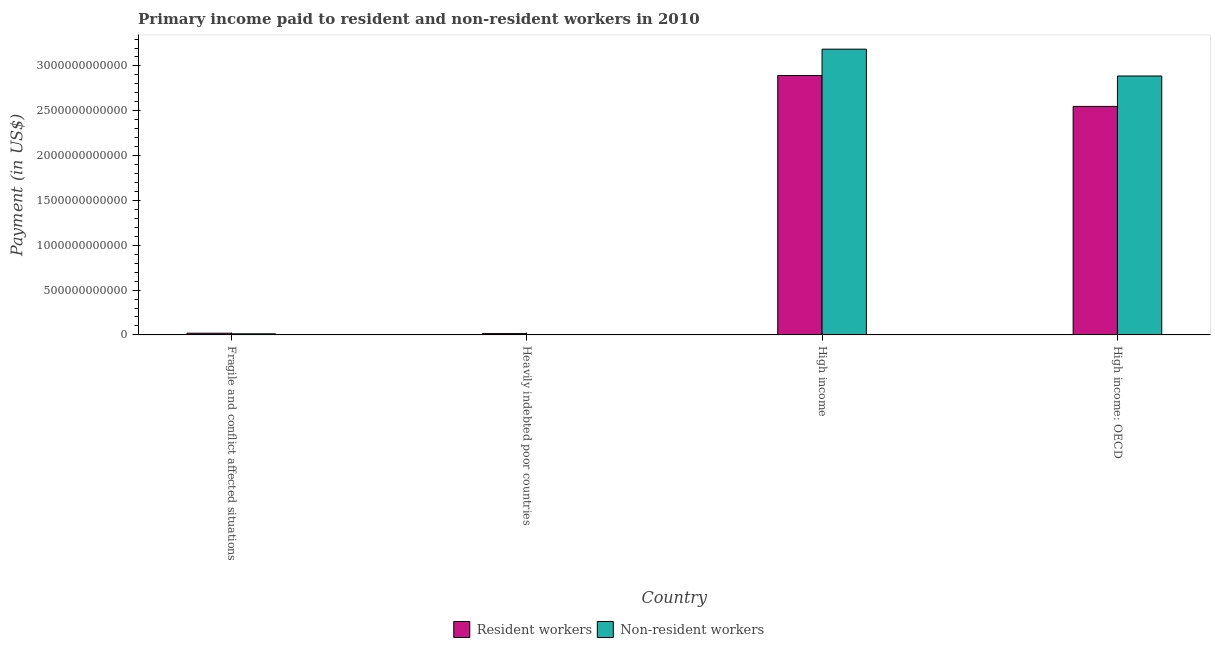Are the number of bars per tick equal to the number of legend labels?
Make the answer very short. Yes. How many bars are there on the 2nd tick from the left?
Your response must be concise. 2. What is the label of the 2nd group of bars from the left?
Ensure brevity in your answer.  Heavily indebted poor countries. In how many cases, is the number of bars for a given country not equal to the number of legend labels?
Provide a short and direct response. 0. What is the payment made to non-resident workers in High income?
Your response must be concise. 3.19e+12. Across all countries, what is the maximum payment made to non-resident workers?
Ensure brevity in your answer.  3.19e+12. Across all countries, what is the minimum payment made to resident workers?
Provide a succinct answer. 1.46e+1. In which country was the payment made to resident workers minimum?
Offer a terse response. Heavily indebted poor countries. What is the total payment made to resident workers in the graph?
Make the answer very short. 5.48e+12. What is the difference between the payment made to non-resident workers in Fragile and conflict affected situations and that in High income: OECD?
Keep it short and to the point. -2.88e+12. What is the difference between the payment made to resident workers in High income and the payment made to non-resident workers in Fragile and conflict affected situations?
Offer a very short reply. 2.88e+12. What is the average payment made to non-resident workers per country?
Provide a short and direct response. 1.52e+12. What is the difference between the payment made to resident workers and payment made to non-resident workers in High income: OECD?
Offer a very short reply. -3.39e+11. In how many countries, is the payment made to non-resident workers greater than 1200000000000 US$?
Your response must be concise. 2. What is the ratio of the payment made to resident workers in Fragile and conflict affected situations to that in High income?
Your answer should be very brief. 0.01. Is the difference between the payment made to resident workers in High income and High income: OECD greater than the difference between the payment made to non-resident workers in High income and High income: OECD?
Provide a short and direct response. Yes. What is the difference between the highest and the second highest payment made to non-resident workers?
Your response must be concise. 2.99e+11. What is the difference between the highest and the lowest payment made to resident workers?
Offer a very short reply. 2.88e+12. In how many countries, is the payment made to non-resident workers greater than the average payment made to non-resident workers taken over all countries?
Your answer should be compact. 2. Is the sum of the payment made to resident workers in High income and High income: OECD greater than the maximum payment made to non-resident workers across all countries?
Offer a very short reply. Yes. What does the 1st bar from the left in Fragile and conflict affected situations represents?
Provide a succinct answer. Resident workers. What does the 1st bar from the right in High income: OECD represents?
Provide a succinct answer. Non-resident workers. How many bars are there?
Provide a short and direct response. 8. How many countries are there in the graph?
Your answer should be very brief. 4. What is the difference between two consecutive major ticks on the Y-axis?
Give a very brief answer. 5.00e+11. Are the values on the major ticks of Y-axis written in scientific E-notation?
Your answer should be compact. No. How many legend labels are there?
Give a very brief answer. 2. What is the title of the graph?
Offer a very short reply. Primary income paid to resident and non-resident workers in 2010. Does "Time to import" appear as one of the legend labels in the graph?
Your answer should be very brief. No. What is the label or title of the Y-axis?
Provide a short and direct response. Payment (in US$). What is the Payment (in US$) of Resident workers in Fragile and conflict affected situations?
Provide a short and direct response. 1.89e+1. What is the Payment (in US$) in Non-resident workers in Fragile and conflict affected situations?
Give a very brief answer. 1.21e+1. What is the Payment (in US$) in Resident workers in Heavily indebted poor countries?
Your response must be concise. 1.46e+1. What is the Payment (in US$) of Non-resident workers in Heavily indebted poor countries?
Your answer should be very brief. 2.23e+09. What is the Payment (in US$) of Resident workers in High income?
Provide a short and direct response. 2.89e+12. What is the Payment (in US$) of Non-resident workers in High income?
Give a very brief answer. 3.19e+12. What is the Payment (in US$) of Resident workers in High income: OECD?
Keep it short and to the point. 2.55e+12. What is the Payment (in US$) in Non-resident workers in High income: OECD?
Your answer should be compact. 2.89e+12. Across all countries, what is the maximum Payment (in US$) of Resident workers?
Make the answer very short. 2.89e+12. Across all countries, what is the maximum Payment (in US$) in Non-resident workers?
Provide a short and direct response. 3.19e+12. Across all countries, what is the minimum Payment (in US$) in Resident workers?
Provide a succinct answer. 1.46e+1. Across all countries, what is the minimum Payment (in US$) of Non-resident workers?
Keep it short and to the point. 2.23e+09. What is the total Payment (in US$) in Resident workers in the graph?
Keep it short and to the point. 5.48e+12. What is the total Payment (in US$) in Non-resident workers in the graph?
Your response must be concise. 6.09e+12. What is the difference between the Payment (in US$) in Resident workers in Fragile and conflict affected situations and that in Heavily indebted poor countries?
Your response must be concise. 4.34e+09. What is the difference between the Payment (in US$) in Non-resident workers in Fragile and conflict affected situations and that in Heavily indebted poor countries?
Your answer should be very brief. 9.86e+09. What is the difference between the Payment (in US$) of Resident workers in Fragile and conflict affected situations and that in High income?
Provide a succinct answer. -2.87e+12. What is the difference between the Payment (in US$) in Non-resident workers in Fragile and conflict affected situations and that in High income?
Offer a terse response. -3.18e+12. What is the difference between the Payment (in US$) of Resident workers in Fragile and conflict affected situations and that in High income: OECD?
Provide a short and direct response. -2.53e+12. What is the difference between the Payment (in US$) in Non-resident workers in Fragile and conflict affected situations and that in High income: OECD?
Your response must be concise. -2.88e+12. What is the difference between the Payment (in US$) in Resident workers in Heavily indebted poor countries and that in High income?
Offer a terse response. -2.88e+12. What is the difference between the Payment (in US$) in Non-resident workers in Heavily indebted poor countries and that in High income?
Offer a very short reply. -3.19e+12. What is the difference between the Payment (in US$) in Resident workers in Heavily indebted poor countries and that in High income: OECD?
Provide a succinct answer. -2.53e+12. What is the difference between the Payment (in US$) of Non-resident workers in Heavily indebted poor countries and that in High income: OECD?
Provide a short and direct response. -2.89e+12. What is the difference between the Payment (in US$) of Resident workers in High income and that in High income: OECD?
Keep it short and to the point. 3.45e+11. What is the difference between the Payment (in US$) of Non-resident workers in High income and that in High income: OECD?
Make the answer very short. 2.99e+11. What is the difference between the Payment (in US$) of Resident workers in Fragile and conflict affected situations and the Payment (in US$) of Non-resident workers in Heavily indebted poor countries?
Your response must be concise. 1.67e+1. What is the difference between the Payment (in US$) in Resident workers in Fragile and conflict affected situations and the Payment (in US$) in Non-resident workers in High income?
Offer a very short reply. -3.17e+12. What is the difference between the Payment (in US$) of Resident workers in Fragile and conflict affected situations and the Payment (in US$) of Non-resident workers in High income: OECD?
Make the answer very short. -2.87e+12. What is the difference between the Payment (in US$) in Resident workers in Heavily indebted poor countries and the Payment (in US$) in Non-resident workers in High income?
Provide a short and direct response. -3.17e+12. What is the difference between the Payment (in US$) of Resident workers in Heavily indebted poor countries and the Payment (in US$) of Non-resident workers in High income: OECD?
Make the answer very short. -2.87e+12. What is the difference between the Payment (in US$) of Resident workers in High income and the Payment (in US$) of Non-resident workers in High income: OECD?
Offer a very short reply. 5.77e+09. What is the average Payment (in US$) in Resident workers per country?
Ensure brevity in your answer.  1.37e+12. What is the average Payment (in US$) in Non-resident workers per country?
Your response must be concise. 1.52e+12. What is the difference between the Payment (in US$) of Resident workers and Payment (in US$) of Non-resident workers in Fragile and conflict affected situations?
Your answer should be very brief. 6.80e+09. What is the difference between the Payment (in US$) in Resident workers and Payment (in US$) in Non-resident workers in Heavily indebted poor countries?
Your response must be concise. 1.23e+1. What is the difference between the Payment (in US$) in Resident workers and Payment (in US$) in Non-resident workers in High income?
Provide a short and direct response. -2.94e+11. What is the difference between the Payment (in US$) in Resident workers and Payment (in US$) in Non-resident workers in High income: OECD?
Ensure brevity in your answer.  -3.39e+11. What is the ratio of the Payment (in US$) in Resident workers in Fragile and conflict affected situations to that in Heavily indebted poor countries?
Make the answer very short. 1.3. What is the ratio of the Payment (in US$) in Non-resident workers in Fragile and conflict affected situations to that in Heavily indebted poor countries?
Make the answer very short. 5.42. What is the ratio of the Payment (in US$) in Resident workers in Fragile and conflict affected situations to that in High income?
Provide a succinct answer. 0.01. What is the ratio of the Payment (in US$) of Non-resident workers in Fragile and conflict affected situations to that in High income?
Your answer should be compact. 0. What is the ratio of the Payment (in US$) of Resident workers in Fragile and conflict affected situations to that in High income: OECD?
Give a very brief answer. 0.01. What is the ratio of the Payment (in US$) in Non-resident workers in Fragile and conflict affected situations to that in High income: OECD?
Provide a short and direct response. 0. What is the ratio of the Payment (in US$) of Resident workers in Heavily indebted poor countries to that in High income?
Provide a succinct answer. 0.01. What is the ratio of the Payment (in US$) in Non-resident workers in Heavily indebted poor countries to that in High income?
Your response must be concise. 0. What is the ratio of the Payment (in US$) in Resident workers in Heavily indebted poor countries to that in High income: OECD?
Your answer should be very brief. 0.01. What is the ratio of the Payment (in US$) in Non-resident workers in Heavily indebted poor countries to that in High income: OECD?
Make the answer very short. 0. What is the ratio of the Payment (in US$) in Resident workers in High income to that in High income: OECD?
Your response must be concise. 1.14. What is the ratio of the Payment (in US$) of Non-resident workers in High income to that in High income: OECD?
Your answer should be compact. 1.1. What is the difference between the highest and the second highest Payment (in US$) in Resident workers?
Make the answer very short. 3.45e+11. What is the difference between the highest and the second highest Payment (in US$) in Non-resident workers?
Offer a terse response. 2.99e+11. What is the difference between the highest and the lowest Payment (in US$) in Resident workers?
Your answer should be very brief. 2.88e+12. What is the difference between the highest and the lowest Payment (in US$) of Non-resident workers?
Give a very brief answer. 3.19e+12. 